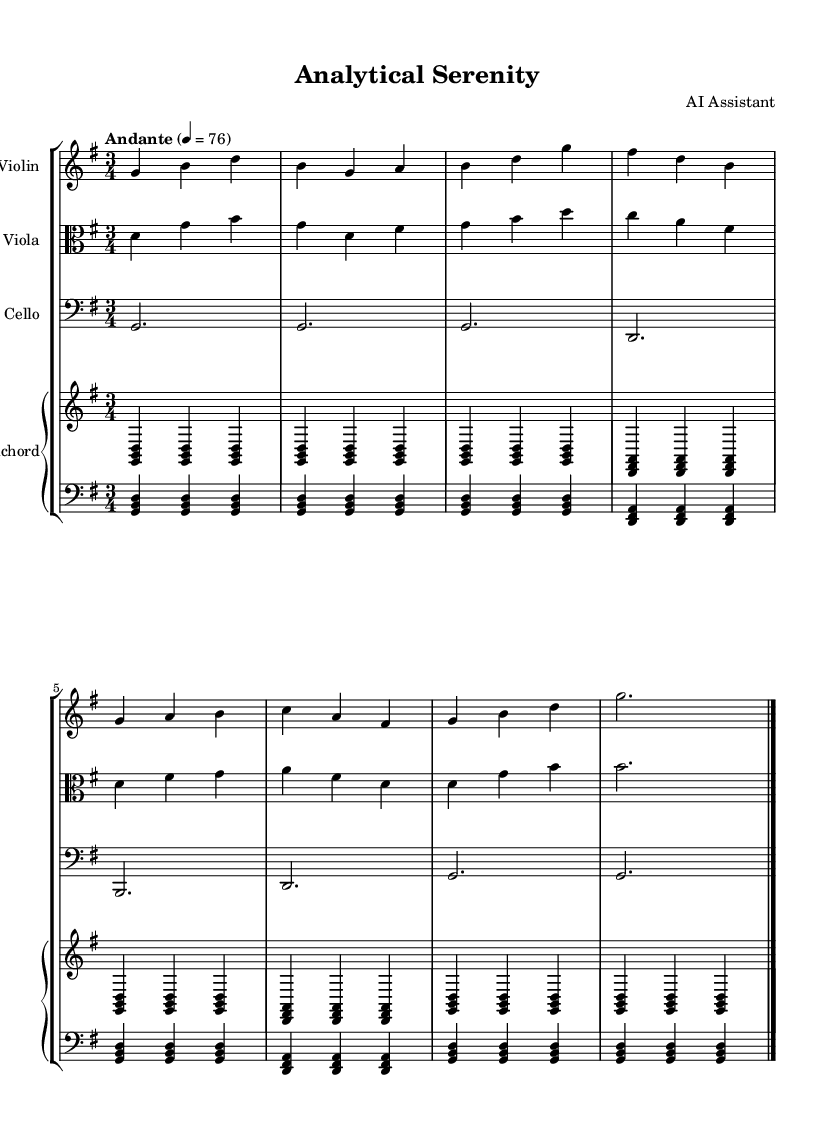What is the key signature of this music? The key signature is G major, which has one sharp (F#). This can be determined by looking at the key signature indicated at the beginning of the score.
Answer: G major What is the time signature of this piece? The time signature is 3/4, which is indicated right after the key signature. This means there are three beats per measure, and the quarter note gets one beat.
Answer: 3/4 What tempo marking is indicated for this piece? The tempo marking is Andante, which implies a moderate pace. It is specified with a metronome marking of 76 beats per minute. This tempo is found at the start of the score.
Answer: Andante How many total measures are present in the score? The score has a total of eight measures. This can be counted by identifying the bar lines separating the measures throughout the piece.
Answer: 8 What instruments are used in this chamber music? The instruments included are Violin, Viola, Cello, and Harpsichord. Each instrument has its staff represented in the score, showing the ensemble's composition.
Answer: Violin, Viola, Cello, Harpsichord What is the duration of the first note played by the cello? The first note played by the cello is a half note, which lasts for two beats. This is evident from the note value written in the cello part at the beginning of the score.
Answer: Half note What type of musical texture is primarily displayed in this composition? The texture of this piece is primarily polyphonic, as multiple independent melodic lines (from different instruments) interact simultaneously. This can be understood by analyzing the interplay between the voices of the instruments throughout the score.
Answer: Polyphonic 